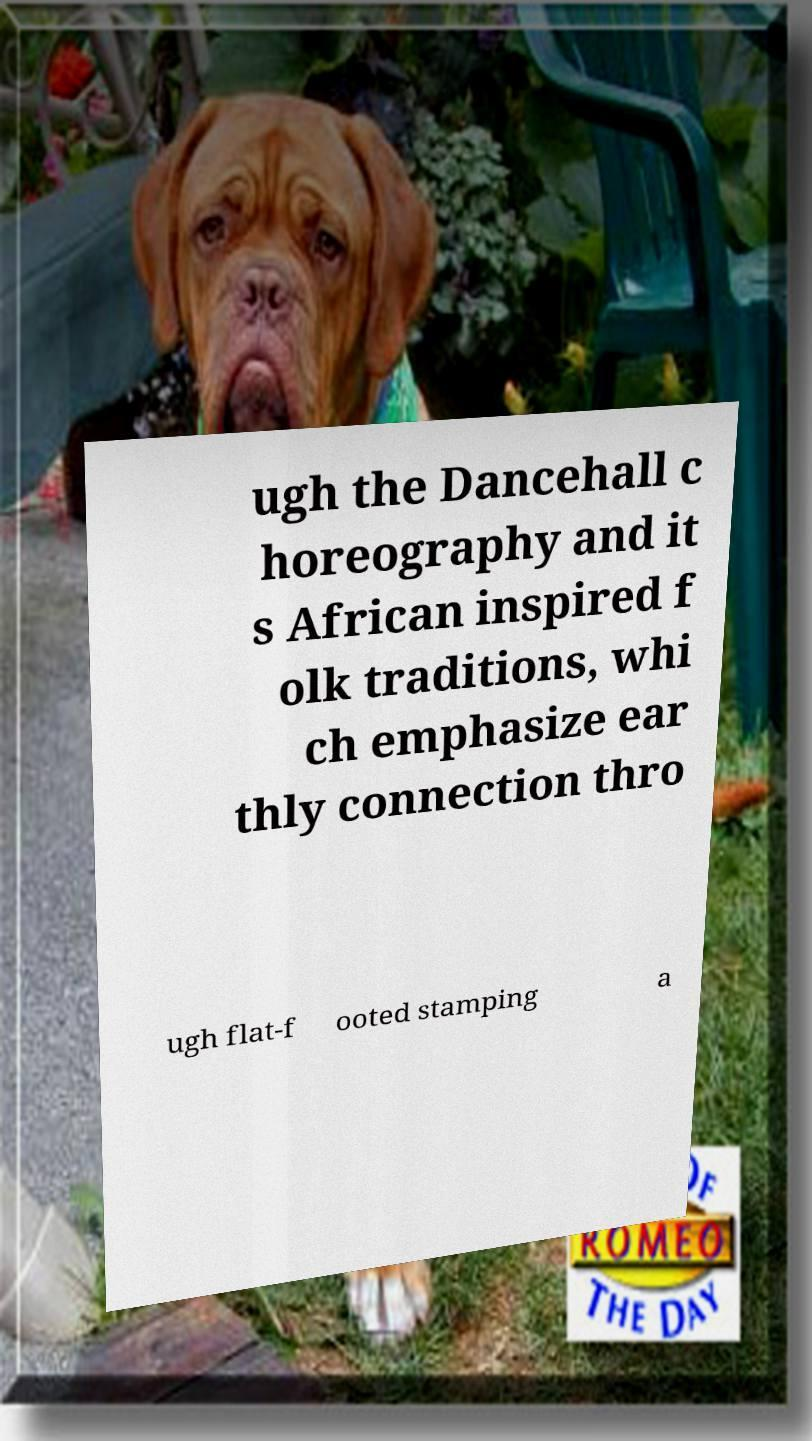Can you accurately transcribe the text from the provided image for me? ugh the Dancehall c horeography and it s African inspired f olk traditions, whi ch emphasize ear thly connection thro ugh flat-f ooted stamping a 